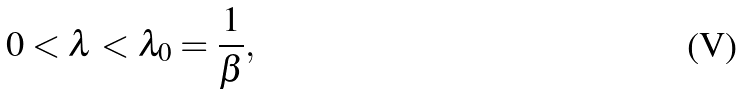Convert formula to latex. <formula><loc_0><loc_0><loc_500><loc_500>0 < \lambda < \lambda _ { 0 } = \frac { 1 } { \beta } ,</formula> 